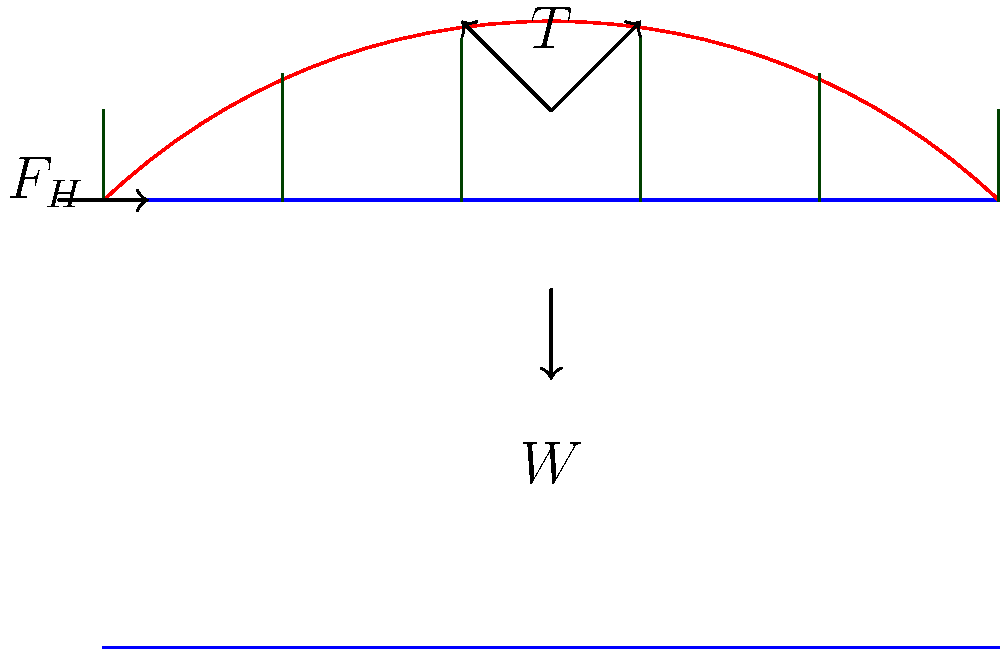In the suspension bridge diagram, the main cable experiences a tension force $T$, and the deck bears a total weight $W$. If the horizontal component of the cable tension at the tower is $F_H$, what is the relationship between these forces at equilibrium? Assume the cable forms a parabolic shape. To determine the relationship between the forces, we'll follow these steps:

1. Recognize that the suspension bridge is in static equilibrium.

2. The main cable forms a parabolic shape, which can be approximated by the equation:
   $$y = \frac{4h}{L^2}x(L-x)$$
   where $h$ is the maximum sag and $L$ is the span length.

3. The slope of the cable at any point is given by:
   $$\frac{dy}{dx} = \frac{4h}{L^2}(L-2x)$$

4. At the tower (x = 0), the slope is maximum:
   $$\left.\frac{dy}{dx}\right|_{x=0} = \frac{4h}{L}$$

5. The tension $T$ can be resolved into horizontal ($F_H$) and vertical ($F_V$) components:
   $$F_H = T \cos\theta$$
   $$F_V = T \sin\theta$$
   where $\theta$ is the angle between the cable and horizontal at the tower.

6. The tangent of this angle is equal to the slope at x = 0:
   $$\tan\theta = \frac{4h}{L} = \frac{F_V}{F_H}$$

7. The vertical component $F_V$ at each tower supports half the total weight $W$:
   $$F_V = \frac{W}{2}$$

8. Substituting this into the equation from step 6:
   $$\frac{4h}{L} = \frac{W}{2F_H}$$

9. Rearranging gives the final relationship:
   $$F_H = \frac{WL}{8h}$$

This equation relates the horizontal force component $F_H$ to the total weight $W$, span length $L$, and maximum sag $h$ of the cable.
Answer: $F_H = \frac{WL}{8h}$ 